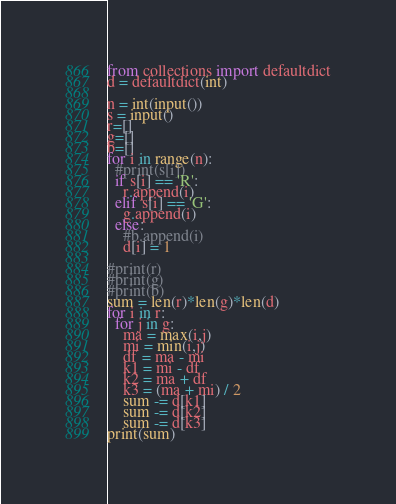Convert code to text. <code><loc_0><loc_0><loc_500><loc_500><_Python_>from collections import defaultdict
d = defaultdict(int)

n = int(input())
s = input()
r=[]
g=[]
b=[]
for i in range(n):
  #print(s[i])
  if s[i] == 'R':
    r.append(i)
  elif s[i] == 'G':
    g.append(i)
  else:
    #b.append(i)
    d[i] = 1

#print(r)
#print(g)
#print(b)
sum = len(r)*len(g)*len(d)
for i in r:
  for j in g:
    ma = max(i,j)
    mi = min(i,j)
    df = ma - mi
    k1 = mi - df
    k2 = ma + df
    k3 = (ma + mi) / 2
    sum -= d[k1]
    sum -= d[k2]
    sum -= d[k3]
print(sum)</code> 